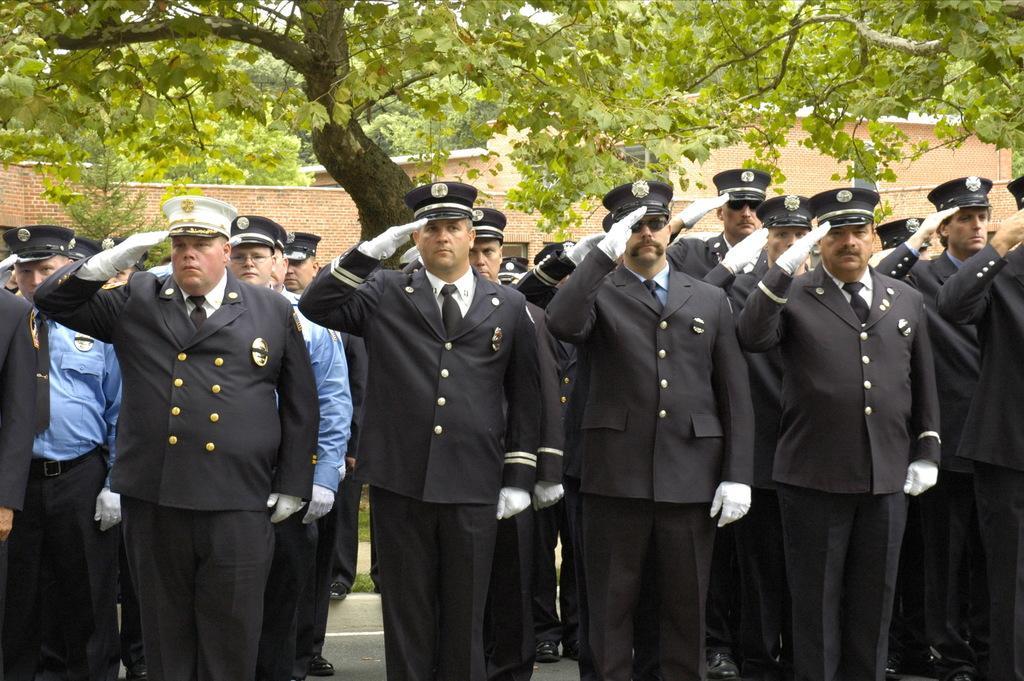Could you give a brief overview of what you see in this image? There are people standing in the foreground area of the image, there are houses and trees in the background. 